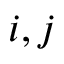Convert formula to latex. <formula><loc_0><loc_0><loc_500><loc_500>i , j</formula> 